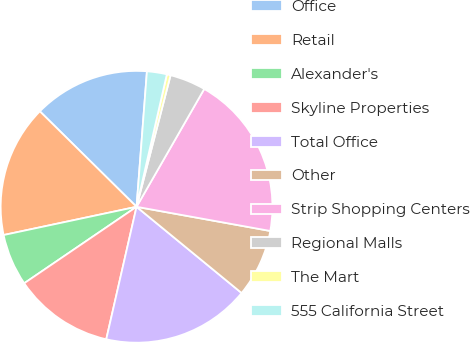<chart> <loc_0><loc_0><loc_500><loc_500><pie_chart><fcel>Office<fcel>Retail<fcel>Alexander's<fcel>Skyline Properties<fcel>Total Office<fcel>Other<fcel>Strip Shopping Centers<fcel>Regional Malls<fcel>The Mart<fcel>555 California Street<nl><fcel>13.82%<fcel>15.73%<fcel>6.18%<fcel>11.91%<fcel>17.64%<fcel>8.09%<fcel>19.55%<fcel>4.27%<fcel>0.45%<fcel>2.36%<nl></chart> 